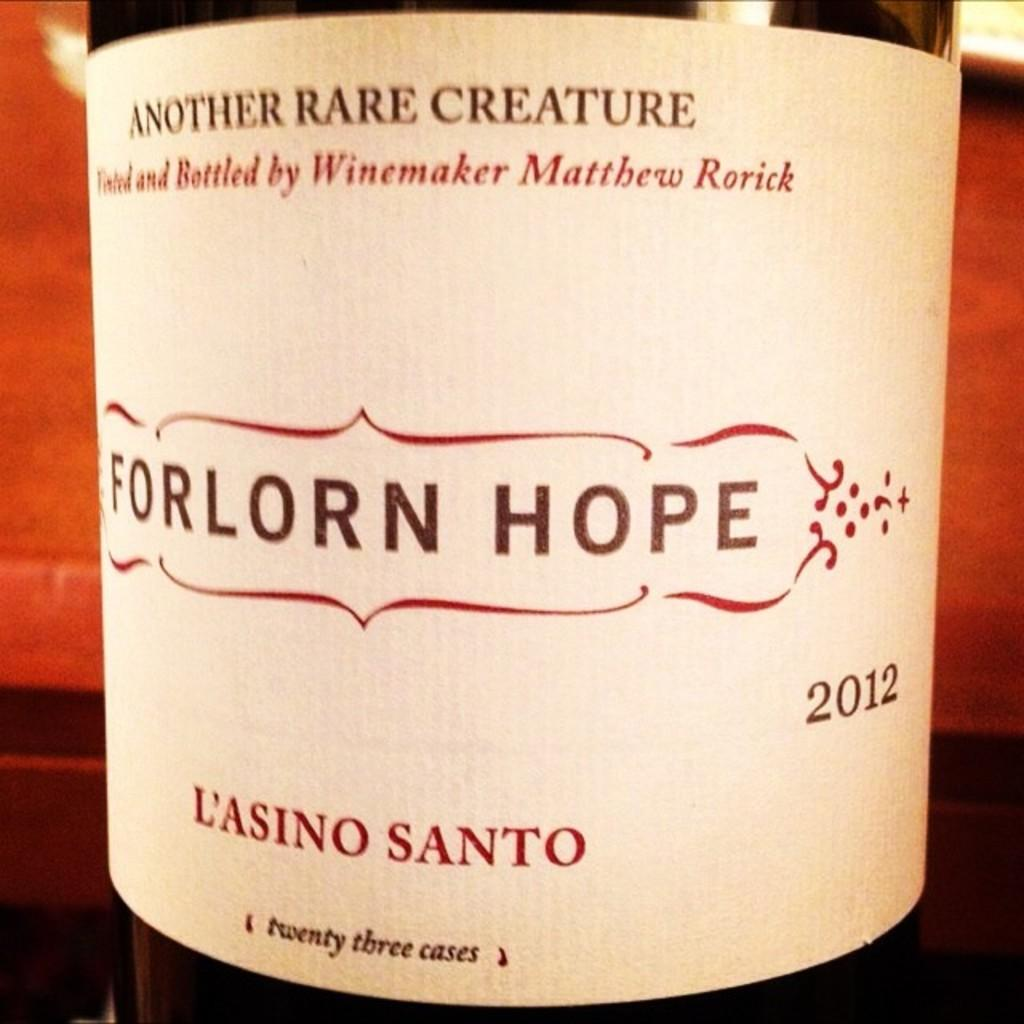<image>
Present a compact description of the photo's key features. A 2012 bottle of wine is dubiously named Forlorn Hope. 